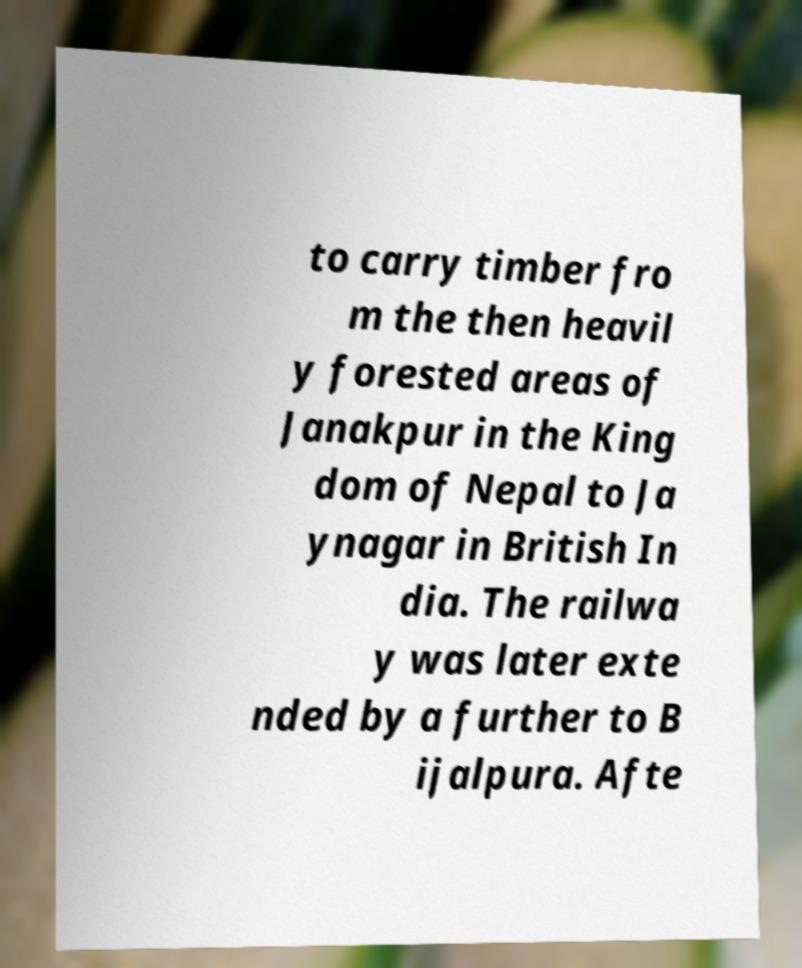Could you assist in decoding the text presented in this image and type it out clearly? to carry timber fro m the then heavil y forested areas of Janakpur in the King dom of Nepal to Ja ynagar in British In dia. The railwa y was later exte nded by a further to B ijalpura. Afte 